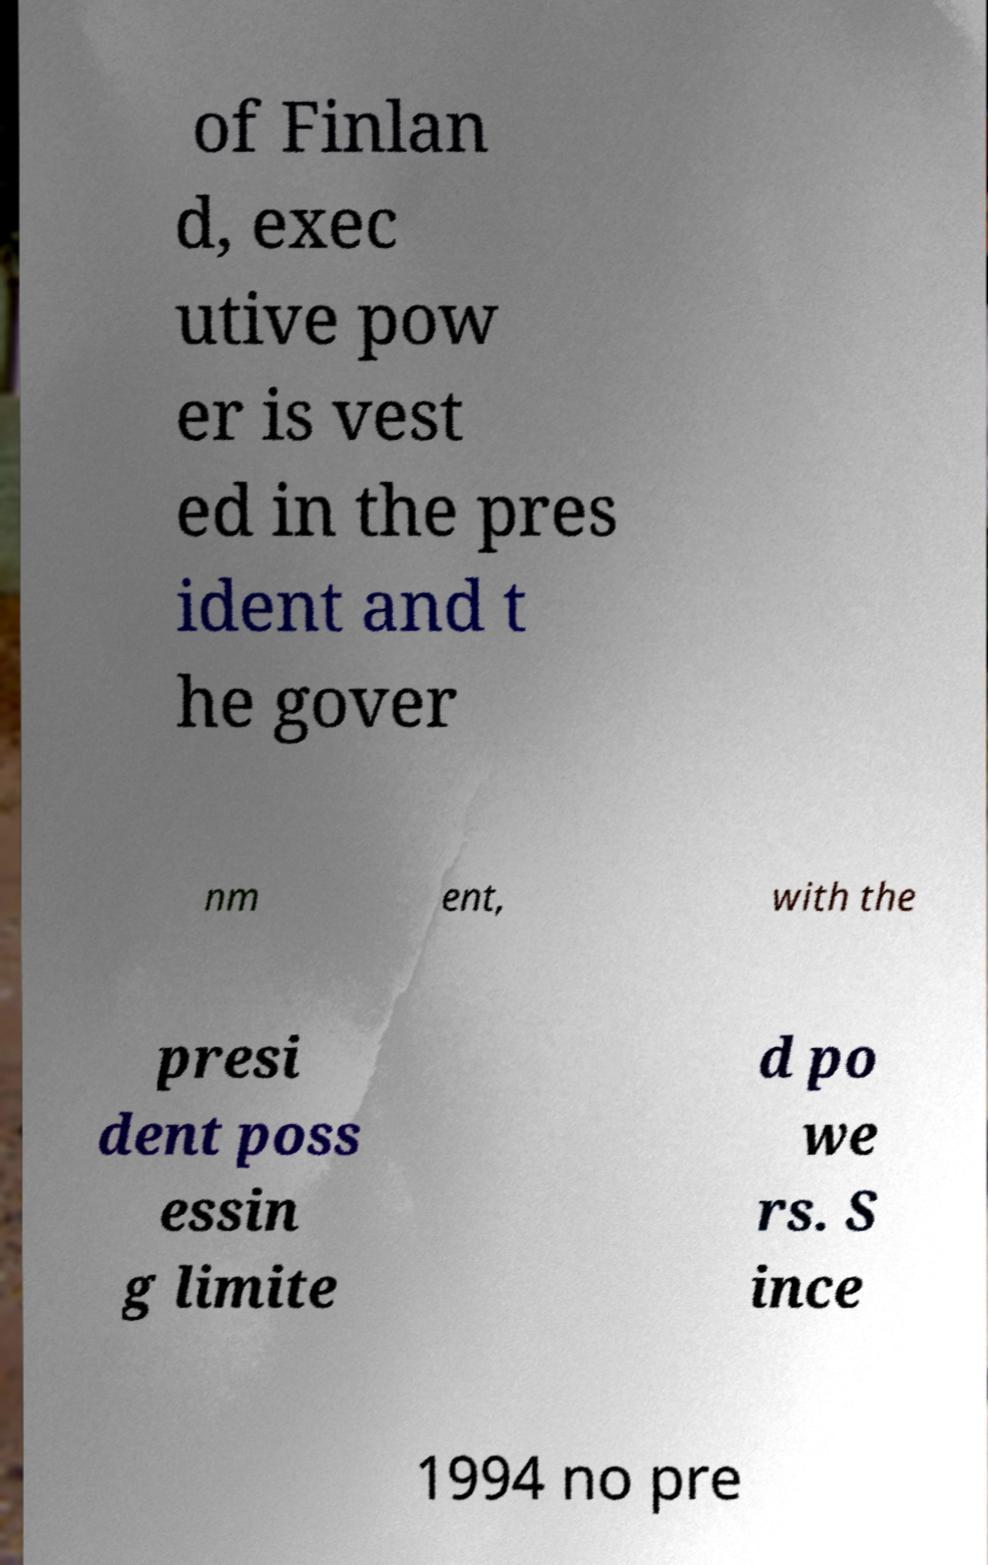There's text embedded in this image that I need extracted. Can you transcribe it verbatim? of Finlan d, exec utive pow er is vest ed in the pres ident and t he gover nm ent, with the presi dent poss essin g limite d po we rs. S ince 1994 no pre 